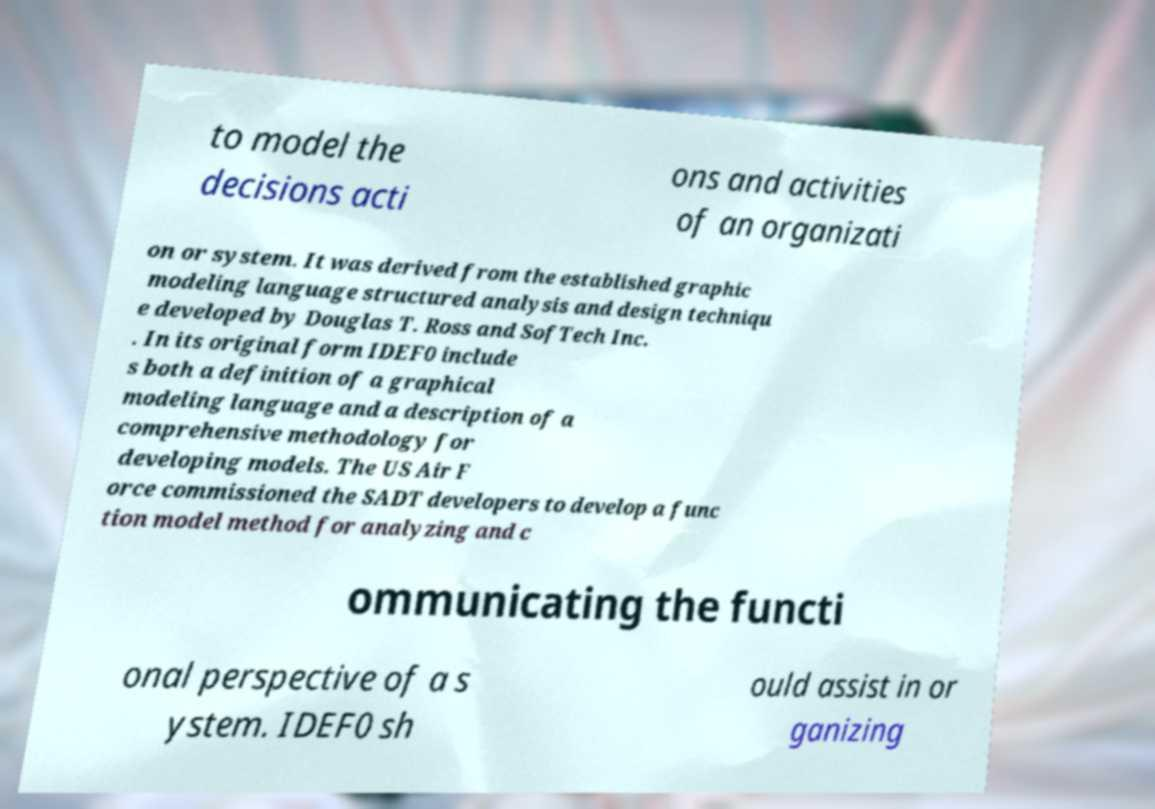Can you read and provide the text displayed in the image?This photo seems to have some interesting text. Can you extract and type it out for me? to model the decisions acti ons and activities of an organizati on or system. It was derived from the established graphic modeling language structured analysis and design techniqu e developed by Douglas T. Ross and SofTech Inc. . In its original form IDEF0 include s both a definition of a graphical modeling language and a description of a comprehensive methodology for developing models. The US Air F orce commissioned the SADT developers to develop a func tion model method for analyzing and c ommunicating the functi onal perspective of a s ystem. IDEF0 sh ould assist in or ganizing 